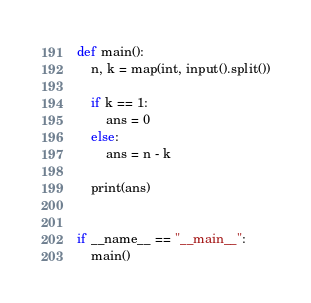Convert code to text. <code><loc_0><loc_0><loc_500><loc_500><_Python_>def main():
    n, k = map(int, input().split())

    if k == 1:
        ans = 0
    else:
        ans = n - k

    print(ans)


if __name__ == "__main__":
    main()
</code> 